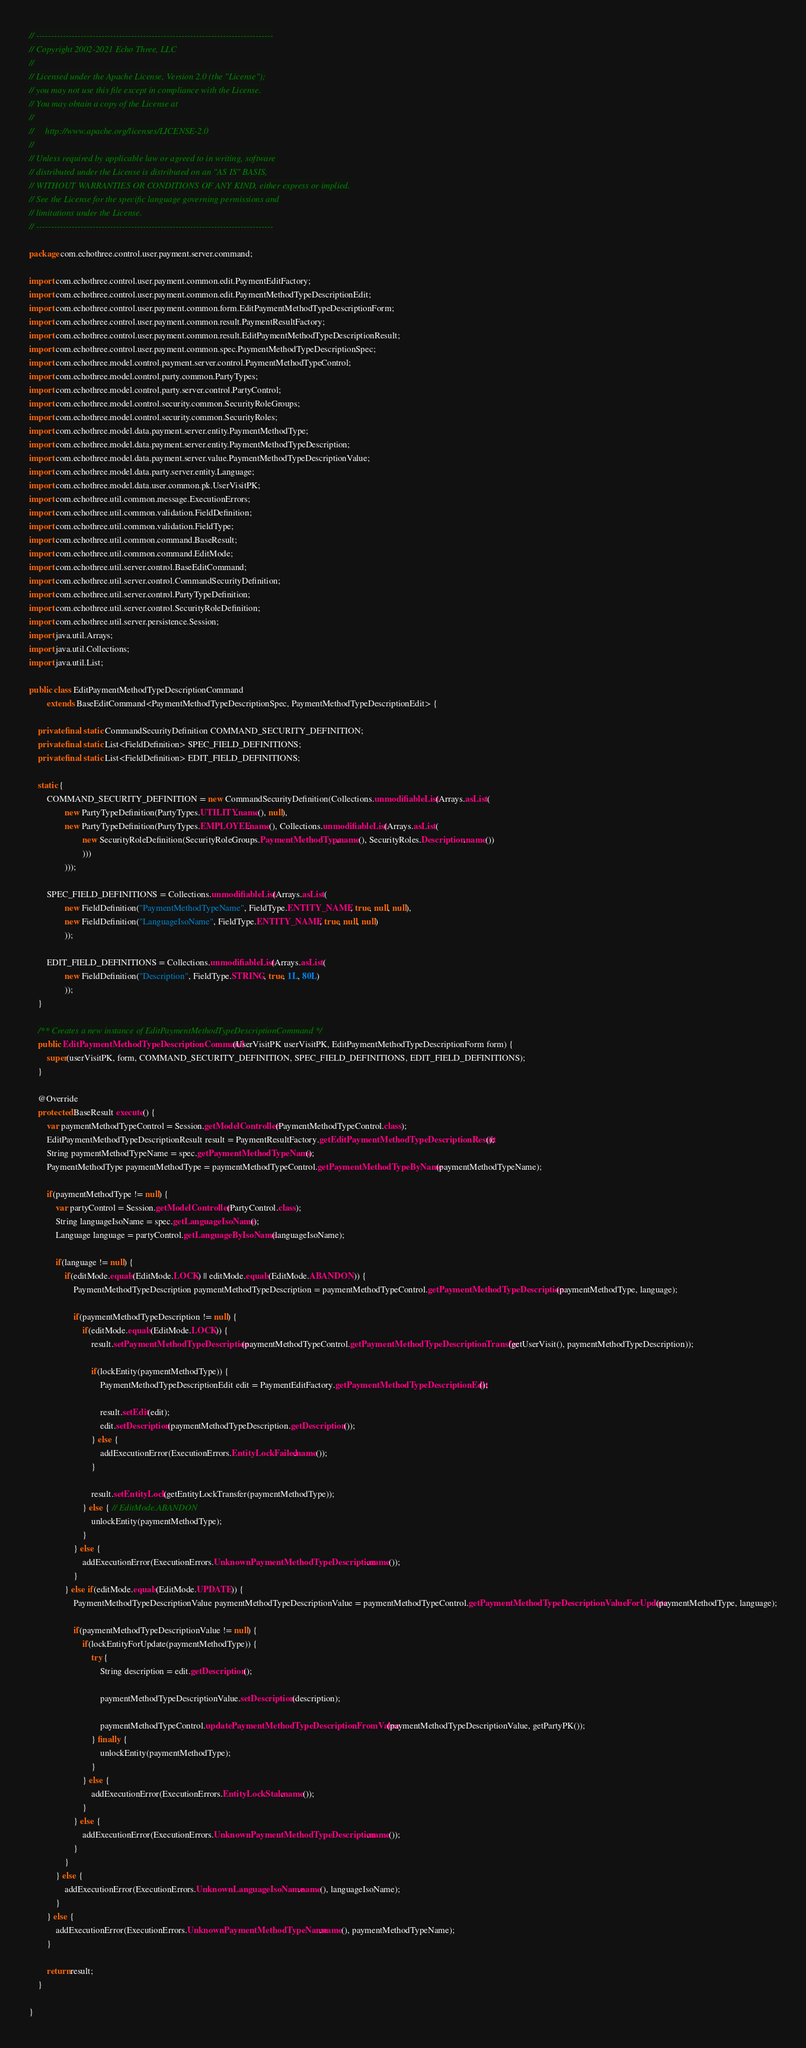<code> <loc_0><loc_0><loc_500><loc_500><_Java_>// --------------------------------------------------------------------------------
// Copyright 2002-2021 Echo Three, LLC
//
// Licensed under the Apache License, Version 2.0 (the "License");
// you may not use this file except in compliance with the License.
// You may obtain a copy of the License at
//
//     http://www.apache.org/licenses/LICENSE-2.0
//
// Unless required by applicable law or agreed to in writing, software
// distributed under the License is distributed on an "AS IS" BASIS,
// WITHOUT WARRANTIES OR CONDITIONS OF ANY KIND, either express or implied.
// See the License for the specific language governing permissions and
// limitations under the License.
// --------------------------------------------------------------------------------

package com.echothree.control.user.payment.server.command;

import com.echothree.control.user.payment.common.edit.PaymentEditFactory;
import com.echothree.control.user.payment.common.edit.PaymentMethodTypeDescriptionEdit;
import com.echothree.control.user.payment.common.form.EditPaymentMethodTypeDescriptionForm;
import com.echothree.control.user.payment.common.result.PaymentResultFactory;
import com.echothree.control.user.payment.common.result.EditPaymentMethodTypeDescriptionResult;
import com.echothree.control.user.payment.common.spec.PaymentMethodTypeDescriptionSpec;
import com.echothree.model.control.payment.server.control.PaymentMethodTypeControl;
import com.echothree.model.control.party.common.PartyTypes;
import com.echothree.model.control.party.server.control.PartyControl;
import com.echothree.model.control.security.common.SecurityRoleGroups;
import com.echothree.model.control.security.common.SecurityRoles;
import com.echothree.model.data.payment.server.entity.PaymentMethodType;
import com.echothree.model.data.payment.server.entity.PaymentMethodTypeDescription;
import com.echothree.model.data.payment.server.value.PaymentMethodTypeDescriptionValue;
import com.echothree.model.data.party.server.entity.Language;
import com.echothree.model.data.user.common.pk.UserVisitPK;
import com.echothree.util.common.message.ExecutionErrors;
import com.echothree.util.common.validation.FieldDefinition;
import com.echothree.util.common.validation.FieldType;
import com.echothree.util.common.command.BaseResult;
import com.echothree.util.common.command.EditMode;
import com.echothree.util.server.control.BaseEditCommand;
import com.echothree.util.server.control.CommandSecurityDefinition;
import com.echothree.util.server.control.PartyTypeDefinition;
import com.echothree.util.server.control.SecurityRoleDefinition;
import com.echothree.util.server.persistence.Session;
import java.util.Arrays;
import java.util.Collections;
import java.util.List;

public class EditPaymentMethodTypeDescriptionCommand
        extends BaseEditCommand<PaymentMethodTypeDescriptionSpec, PaymentMethodTypeDescriptionEdit> {
    
    private final static CommandSecurityDefinition COMMAND_SECURITY_DEFINITION;
    private final static List<FieldDefinition> SPEC_FIELD_DEFINITIONS;
    private final static List<FieldDefinition> EDIT_FIELD_DEFINITIONS;
    
    static {
        COMMAND_SECURITY_DEFINITION = new CommandSecurityDefinition(Collections.unmodifiableList(Arrays.asList(
                new PartyTypeDefinition(PartyTypes.UTILITY.name(), null),
                new PartyTypeDefinition(PartyTypes.EMPLOYEE.name(), Collections.unmodifiableList(Arrays.asList(
                        new SecurityRoleDefinition(SecurityRoleGroups.PaymentMethodType.name(), SecurityRoles.Description.name())
                        )))
                )));
        
        SPEC_FIELD_DEFINITIONS = Collections.unmodifiableList(Arrays.asList(
                new FieldDefinition("PaymentMethodTypeName", FieldType.ENTITY_NAME, true, null, null),
                new FieldDefinition("LanguageIsoName", FieldType.ENTITY_NAME, true, null, null)
                ));
        
        EDIT_FIELD_DEFINITIONS = Collections.unmodifiableList(Arrays.asList(
                new FieldDefinition("Description", FieldType.STRING, true, 1L, 80L)
                ));
    }
    
    /** Creates a new instance of EditPaymentMethodTypeDescriptionCommand */
    public EditPaymentMethodTypeDescriptionCommand(UserVisitPK userVisitPK, EditPaymentMethodTypeDescriptionForm form) {
        super(userVisitPK, form, COMMAND_SECURITY_DEFINITION, SPEC_FIELD_DEFINITIONS, EDIT_FIELD_DEFINITIONS);
    }
    
    @Override
    protected BaseResult execute() {
        var paymentMethodTypeControl = Session.getModelController(PaymentMethodTypeControl.class);
        EditPaymentMethodTypeDescriptionResult result = PaymentResultFactory.getEditPaymentMethodTypeDescriptionResult();
        String paymentMethodTypeName = spec.getPaymentMethodTypeName();
        PaymentMethodType paymentMethodType = paymentMethodTypeControl.getPaymentMethodTypeByName(paymentMethodTypeName);
        
        if(paymentMethodType != null) {
            var partyControl = Session.getModelController(PartyControl.class);
            String languageIsoName = spec.getLanguageIsoName();
            Language language = partyControl.getLanguageByIsoName(languageIsoName);
            
            if(language != null) {
                if(editMode.equals(EditMode.LOCK) || editMode.equals(EditMode.ABANDON)) {
                    PaymentMethodTypeDescription paymentMethodTypeDescription = paymentMethodTypeControl.getPaymentMethodTypeDescription(paymentMethodType, language);
                    
                    if(paymentMethodTypeDescription != null) {
                        if(editMode.equals(EditMode.LOCK)) {
                            result.setPaymentMethodTypeDescription(paymentMethodTypeControl.getPaymentMethodTypeDescriptionTransfer(getUserVisit(), paymentMethodTypeDescription));

                            if(lockEntity(paymentMethodType)) {
                                PaymentMethodTypeDescriptionEdit edit = PaymentEditFactory.getPaymentMethodTypeDescriptionEdit();

                                result.setEdit(edit);
                                edit.setDescription(paymentMethodTypeDescription.getDescription());
                            } else {
                                addExecutionError(ExecutionErrors.EntityLockFailed.name());
                            }

                            result.setEntityLock(getEntityLockTransfer(paymentMethodType));
                        } else { // EditMode.ABANDON
                            unlockEntity(paymentMethodType);
                        }
                    } else {
                        addExecutionError(ExecutionErrors.UnknownPaymentMethodTypeDescription.name());
                    }
                } else if(editMode.equals(EditMode.UPDATE)) {
                    PaymentMethodTypeDescriptionValue paymentMethodTypeDescriptionValue = paymentMethodTypeControl.getPaymentMethodTypeDescriptionValueForUpdate(paymentMethodType, language);
                    
                    if(paymentMethodTypeDescriptionValue != null) {
                        if(lockEntityForUpdate(paymentMethodType)) {
                            try {
                                String description = edit.getDescription();
                                
                                paymentMethodTypeDescriptionValue.setDescription(description);
                                
                                paymentMethodTypeControl.updatePaymentMethodTypeDescriptionFromValue(paymentMethodTypeDescriptionValue, getPartyPK());
                            } finally {
                                unlockEntity(paymentMethodType);
                            }
                        } else {
                            addExecutionError(ExecutionErrors.EntityLockStale.name());
                        }
                    } else {
                        addExecutionError(ExecutionErrors.UnknownPaymentMethodTypeDescription.name());
                    }
                }
            } else {
                addExecutionError(ExecutionErrors.UnknownLanguageIsoName.name(), languageIsoName);
            }
        } else {
            addExecutionError(ExecutionErrors.UnknownPaymentMethodTypeName.name(), paymentMethodTypeName);
        }
        
        return result;
    }
    
}
</code> 